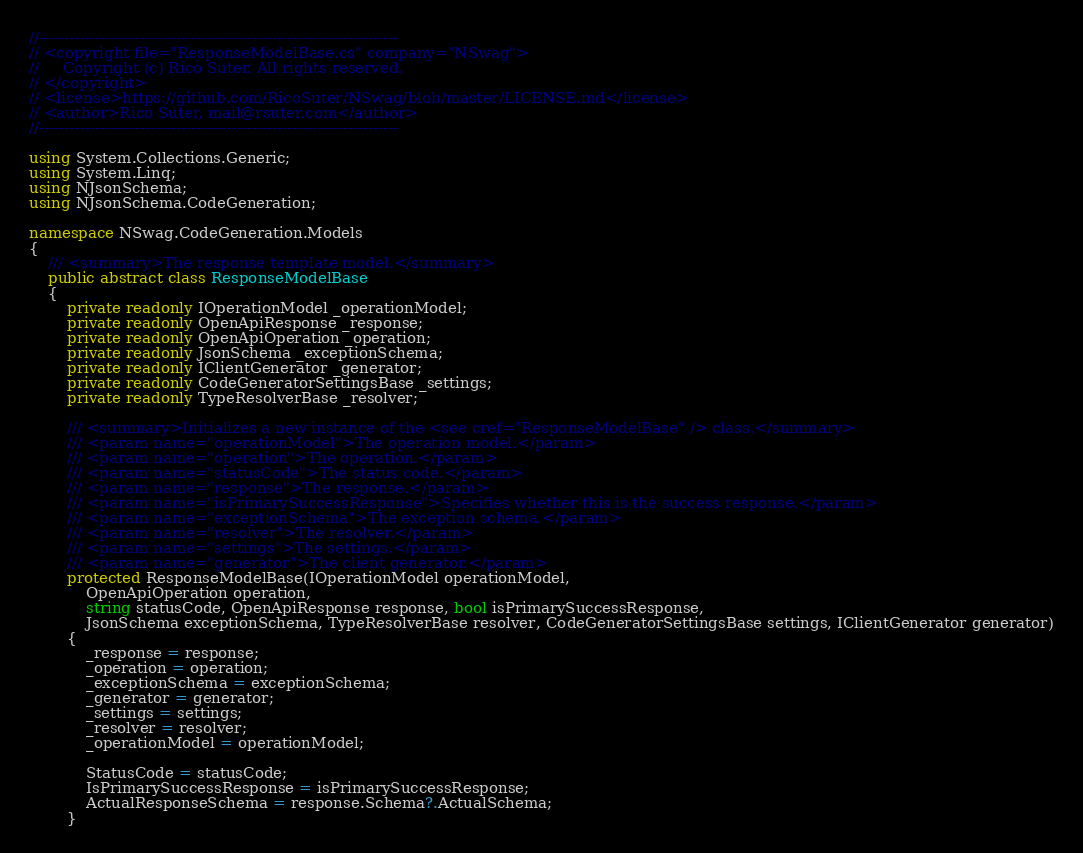Convert code to text. <code><loc_0><loc_0><loc_500><loc_500><_C#_>//-----------------------------------------------------------------------
// <copyright file="ResponseModelBase.cs" company="NSwag">
//     Copyright (c) Rico Suter. All rights reserved.
// </copyright>
// <license>https://github.com/RicoSuter/NSwag/blob/master/LICENSE.md</license>
// <author>Rico Suter, mail@rsuter.com</author>
//-----------------------------------------------------------------------

using System.Collections.Generic;
using System.Linq;
using NJsonSchema;
using NJsonSchema.CodeGeneration;

namespace NSwag.CodeGeneration.Models
{
    /// <summary>The response template model.</summary>
    public abstract class ResponseModelBase
    {
        private readonly IOperationModel _operationModel;
        private readonly OpenApiResponse _response;
        private readonly OpenApiOperation _operation;
        private readonly JsonSchema _exceptionSchema;
        private readonly IClientGenerator _generator;
        private readonly CodeGeneratorSettingsBase _settings;
        private readonly TypeResolverBase _resolver;

        /// <summary>Initializes a new instance of the <see cref="ResponseModelBase" /> class.</summary>
        /// <param name="operationModel">The operation model.</param>
        /// <param name="operation">The operation.</param>
        /// <param name="statusCode">The status code.</param>
        /// <param name="response">The response.</param>
        /// <param name="isPrimarySuccessResponse">Specifies whether this is the success response.</param>
        /// <param name="exceptionSchema">The exception schema.</param>
        /// <param name="resolver">The resolver.</param>
        /// <param name="settings">The settings.</param>
        /// <param name="generator">The client generator.</param>
        protected ResponseModelBase(IOperationModel operationModel,
            OpenApiOperation operation,
            string statusCode, OpenApiResponse response, bool isPrimarySuccessResponse,
            JsonSchema exceptionSchema, TypeResolverBase resolver, CodeGeneratorSettingsBase settings, IClientGenerator generator)
        {
            _response = response;
            _operation = operation;
            _exceptionSchema = exceptionSchema;
            _generator = generator;
            _settings = settings;
            _resolver = resolver;
            _operationModel = operationModel;

            StatusCode = statusCode;
            IsPrimarySuccessResponse = isPrimarySuccessResponse;
            ActualResponseSchema = response.Schema?.ActualSchema;
        }
</code> 